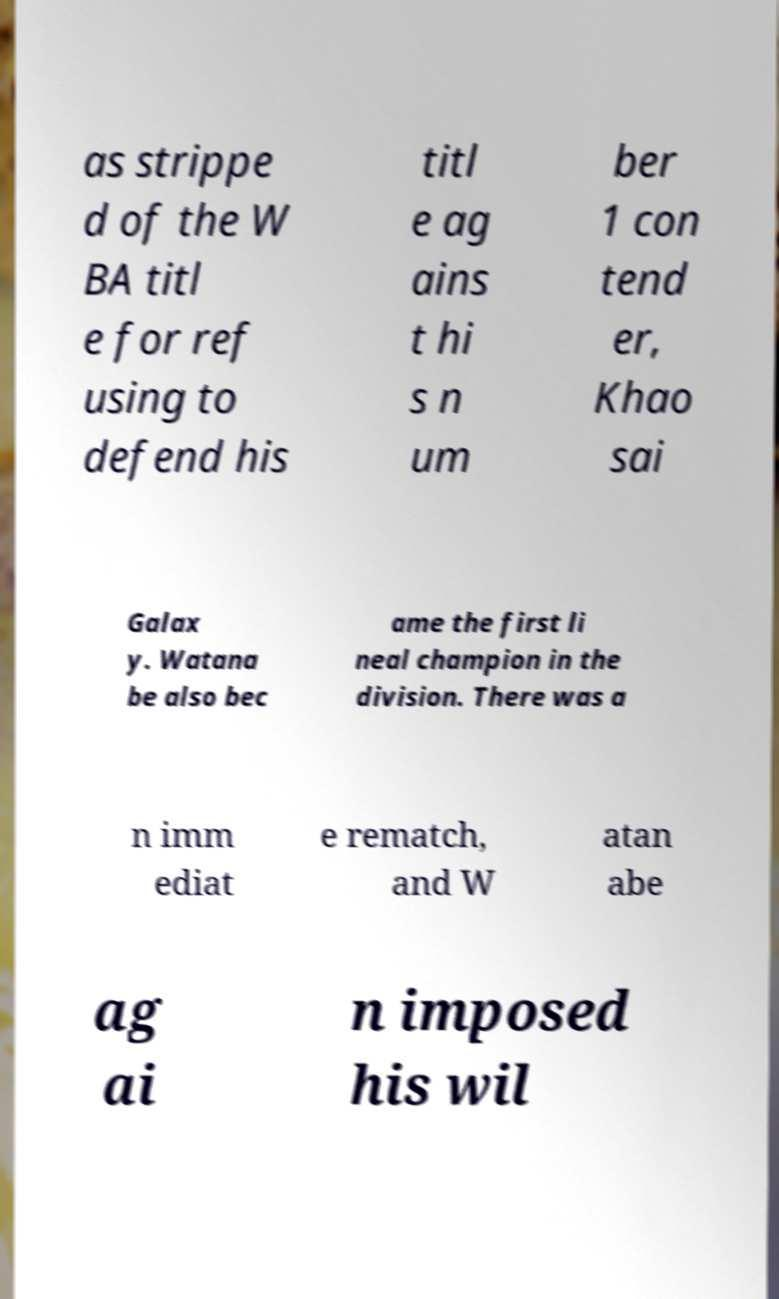There's text embedded in this image that I need extracted. Can you transcribe it verbatim? as strippe d of the W BA titl e for ref using to defend his titl e ag ains t hi s n um ber 1 con tend er, Khao sai Galax y. Watana be also bec ame the first li neal champion in the division. There was a n imm ediat e rematch, and W atan abe ag ai n imposed his wil 